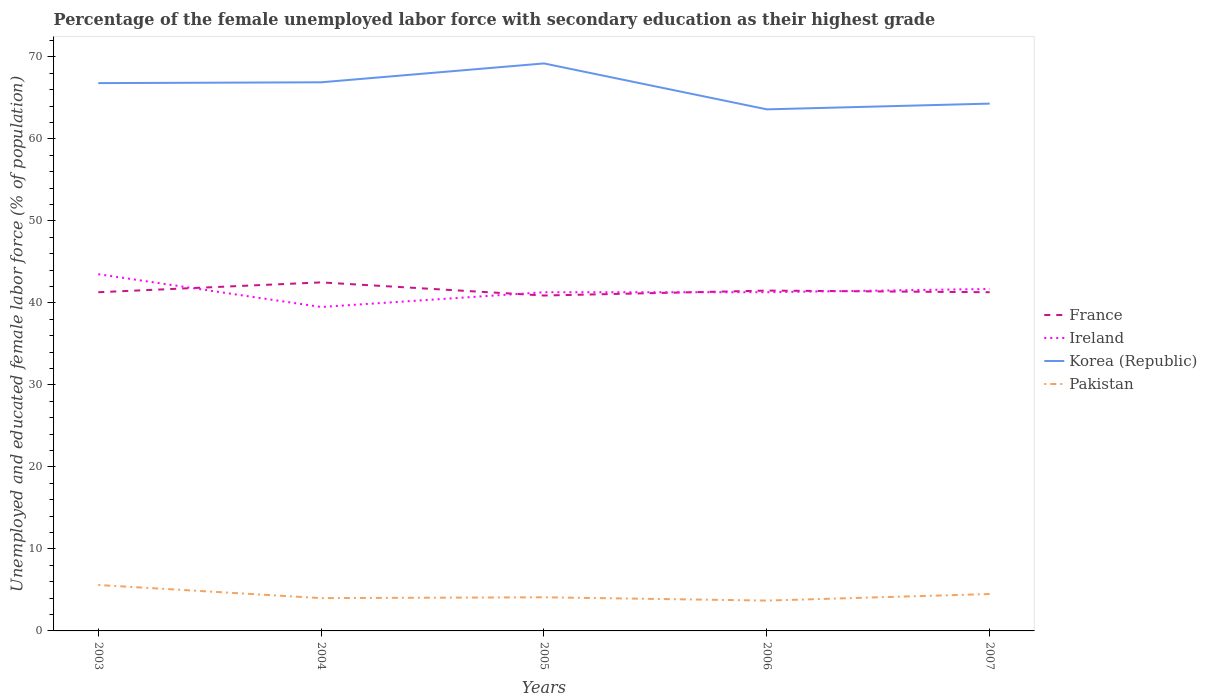Does the line corresponding to Korea (Republic) intersect with the line corresponding to Ireland?
Give a very brief answer. No. Across all years, what is the maximum percentage of the unemployed female labor force with secondary education in Ireland?
Provide a short and direct response. 39.5. What is the total percentage of the unemployed female labor force with secondary education in Ireland in the graph?
Provide a short and direct response. -0.4. What is the difference between the highest and the second highest percentage of the unemployed female labor force with secondary education in France?
Provide a succinct answer. 1.6. What is the difference between the highest and the lowest percentage of the unemployed female labor force with secondary education in Pakistan?
Your response must be concise. 2. Is the percentage of the unemployed female labor force with secondary education in Korea (Republic) strictly greater than the percentage of the unemployed female labor force with secondary education in France over the years?
Offer a terse response. No. How many years are there in the graph?
Give a very brief answer. 5. Does the graph contain any zero values?
Make the answer very short. No. Where does the legend appear in the graph?
Keep it short and to the point. Center right. How many legend labels are there?
Keep it short and to the point. 4. What is the title of the graph?
Provide a short and direct response. Percentage of the female unemployed labor force with secondary education as their highest grade. Does "Senegal" appear as one of the legend labels in the graph?
Give a very brief answer. No. What is the label or title of the Y-axis?
Give a very brief answer. Unemployed and educated female labor force (% of population). What is the Unemployed and educated female labor force (% of population) of France in 2003?
Ensure brevity in your answer.  41.3. What is the Unemployed and educated female labor force (% of population) in Ireland in 2003?
Give a very brief answer. 43.5. What is the Unemployed and educated female labor force (% of population) in Korea (Republic) in 2003?
Keep it short and to the point. 66.8. What is the Unemployed and educated female labor force (% of population) of Pakistan in 2003?
Ensure brevity in your answer.  5.6. What is the Unemployed and educated female labor force (% of population) in France in 2004?
Provide a succinct answer. 42.5. What is the Unemployed and educated female labor force (% of population) in Ireland in 2004?
Offer a very short reply. 39.5. What is the Unemployed and educated female labor force (% of population) of Korea (Republic) in 2004?
Offer a terse response. 66.9. What is the Unemployed and educated female labor force (% of population) in Pakistan in 2004?
Provide a succinct answer. 4. What is the Unemployed and educated female labor force (% of population) of France in 2005?
Offer a very short reply. 40.9. What is the Unemployed and educated female labor force (% of population) in Ireland in 2005?
Ensure brevity in your answer.  41.3. What is the Unemployed and educated female labor force (% of population) in Korea (Republic) in 2005?
Your answer should be very brief. 69.2. What is the Unemployed and educated female labor force (% of population) of Pakistan in 2005?
Your response must be concise. 4.1. What is the Unemployed and educated female labor force (% of population) of France in 2006?
Ensure brevity in your answer.  41.5. What is the Unemployed and educated female labor force (% of population) of Ireland in 2006?
Give a very brief answer. 41.3. What is the Unemployed and educated female labor force (% of population) of Korea (Republic) in 2006?
Provide a short and direct response. 63.6. What is the Unemployed and educated female labor force (% of population) of Pakistan in 2006?
Provide a succinct answer. 3.7. What is the Unemployed and educated female labor force (% of population) in France in 2007?
Give a very brief answer. 41.3. What is the Unemployed and educated female labor force (% of population) in Ireland in 2007?
Provide a succinct answer. 41.7. What is the Unemployed and educated female labor force (% of population) of Korea (Republic) in 2007?
Offer a terse response. 64.3. What is the Unemployed and educated female labor force (% of population) of Pakistan in 2007?
Offer a very short reply. 4.5. Across all years, what is the maximum Unemployed and educated female labor force (% of population) in France?
Your answer should be very brief. 42.5. Across all years, what is the maximum Unemployed and educated female labor force (% of population) in Ireland?
Keep it short and to the point. 43.5. Across all years, what is the maximum Unemployed and educated female labor force (% of population) in Korea (Republic)?
Keep it short and to the point. 69.2. Across all years, what is the maximum Unemployed and educated female labor force (% of population) of Pakistan?
Offer a terse response. 5.6. Across all years, what is the minimum Unemployed and educated female labor force (% of population) of France?
Offer a terse response. 40.9. Across all years, what is the minimum Unemployed and educated female labor force (% of population) of Ireland?
Offer a very short reply. 39.5. Across all years, what is the minimum Unemployed and educated female labor force (% of population) of Korea (Republic)?
Your answer should be compact. 63.6. Across all years, what is the minimum Unemployed and educated female labor force (% of population) in Pakistan?
Your answer should be very brief. 3.7. What is the total Unemployed and educated female labor force (% of population) of France in the graph?
Your answer should be compact. 207.5. What is the total Unemployed and educated female labor force (% of population) of Ireland in the graph?
Offer a terse response. 207.3. What is the total Unemployed and educated female labor force (% of population) in Korea (Republic) in the graph?
Give a very brief answer. 330.8. What is the total Unemployed and educated female labor force (% of population) of Pakistan in the graph?
Offer a very short reply. 21.9. What is the difference between the Unemployed and educated female labor force (% of population) in Ireland in 2003 and that in 2004?
Make the answer very short. 4. What is the difference between the Unemployed and educated female labor force (% of population) of Korea (Republic) in 2003 and that in 2004?
Offer a very short reply. -0.1. What is the difference between the Unemployed and educated female labor force (% of population) in Ireland in 2003 and that in 2005?
Provide a short and direct response. 2.2. What is the difference between the Unemployed and educated female labor force (% of population) in Korea (Republic) in 2003 and that in 2005?
Ensure brevity in your answer.  -2.4. What is the difference between the Unemployed and educated female labor force (% of population) of Korea (Republic) in 2003 and that in 2006?
Ensure brevity in your answer.  3.2. What is the difference between the Unemployed and educated female labor force (% of population) of France in 2003 and that in 2007?
Provide a short and direct response. 0. What is the difference between the Unemployed and educated female labor force (% of population) in Korea (Republic) in 2004 and that in 2005?
Ensure brevity in your answer.  -2.3. What is the difference between the Unemployed and educated female labor force (% of population) in Pakistan in 2004 and that in 2005?
Keep it short and to the point. -0.1. What is the difference between the Unemployed and educated female labor force (% of population) in France in 2004 and that in 2006?
Your response must be concise. 1. What is the difference between the Unemployed and educated female labor force (% of population) in Korea (Republic) in 2004 and that in 2006?
Your answer should be compact. 3.3. What is the difference between the Unemployed and educated female labor force (% of population) of Pakistan in 2004 and that in 2006?
Provide a short and direct response. 0.3. What is the difference between the Unemployed and educated female labor force (% of population) in France in 2004 and that in 2007?
Your answer should be compact. 1.2. What is the difference between the Unemployed and educated female labor force (% of population) in Ireland in 2004 and that in 2007?
Your answer should be very brief. -2.2. What is the difference between the Unemployed and educated female labor force (% of population) in Korea (Republic) in 2004 and that in 2007?
Ensure brevity in your answer.  2.6. What is the difference between the Unemployed and educated female labor force (% of population) in Ireland in 2005 and that in 2006?
Give a very brief answer. 0. What is the difference between the Unemployed and educated female labor force (% of population) of Korea (Republic) in 2005 and that in 2006?
Provide a short and direct response. 5.6. What is the difference between the Unemployed and educated female labor force (% of population) of Pakistan in 2005 and that in 2006?
Offer a terse response. 0.4. What is the difference between the Unemployed and educated female labor force (% of population) in France in 2005 and that in 2007?
Your answer should be very brief. -0.4. What is the difference between the Unemployed and educated female labor force (% of population) of Ireland in 2005 and that in 2007?
Make the answer very short. -0.4. What is the difference between the Unemployed and educated female labor force (% of population) in Korea (Republic) in 2005 and that in 2007?
Offer a very short reply. 4.9. What is the difference between the Unemployed and educated female labor force (% of population) in Korea (Republic) in 2006 and that in 2007?
Provide a short and direct response. -0.7. What is the difference between the Unemployed and educated female labor force (% of population) of France in 2003 and the Unemployed and educated female labor force (% of population) of Ireland in 2004?
Offer a terse response. 1.8. What is the difference between the Unemployed and educated female labor force (% of population) in France in 2003 and the Unemployed and educated female labor force (% of population) in Korea (Republic) in 2004?
Keep it short and to the point. -25.6. What is the difference between the Unemployed and educated female labor force (% of population) in France in 2003 and the Unemployed and educated female labor force (% of population) in Pakistan in 2004?
Ensure brevity in your answer.  37.3. What is the difference between the Unemployed and educated female labor force (% of population) in Ireland in 2003 and the Unemployed and educated female labor force (% of population) in Korea (Republic) in 2004?
Give a very brief answer. -23.4. What is the difference between the Unemployed and educated female labor force (% of population) in Ireland in 2003 and the Unemployed and educated female labor force (% of population) in Pakistan in 2004?
Make the answer very short. 39.5. What is the difference between the Unemployed and educated female labor force (% of population) in Korea (Republic) in 2003 and the Unemployed and educated female labor force (% of population) in Pakistan in 2004?
Offer a very short reply. 62.8. What is the difference between the Unemployed and educated female labor force (% of population) in France in 2003 and the Unemployed and educated female labor force (% of population) in Ireland in 2005?
Offer a very short reply. 0. What is the difference between the Unemployed and educated female labor force (% of population) of France in 2003 and the Unemployed and educated female labor force (% of population) of Korea (Republic) in 2005?
Your answer should be very brief. -27.9. What is the difference between the Unemployed and educated female labor force (% of population) of France in 2003 and the Unemployed and educated female labor force (% of population) of Pakistan in 2005?
Your response must be concise. 37.2. What is the difference between the Unemployed and educated female labor force (% of population) in Ireland in 2003 and the Unemployed and educated female labor force (% of population) in Korea (Republic) in 2005?
Your response must be concise. -25.7. What is the difference between the Unemployed and educated female labor force (% of population) of Ireland in 2003 and the Unemployed and educated female labor force (% of population) of Pakistan in 2005?
Provide a short and direct response. 39.4. What is the difference between the Unemployed and educated female labor force (% of population) of Korea (Republic) in 2003 and the Unemployed and educated female labor force (% of population) of Pakistan in 2005?
Ensure brevity in your answer.  62.7. What is the difference between the Unemployed and educated female labor force (% of population) of France in 2003 and the Unemployed and educated female labor force (% of population) of Ireland in 2006?
Provide a succinct answer. 0. What is the difference between the Unemployed and educated female labor force (% of population) of France in 2003 and the Unemployed and educated female labor force (% of population) of Korea (Republic) in 2006?
Provide a succinct answer. -22.3. What is the difference between the Unemployed and educated female labor force (% of population) in France in 2003 and the Unemployed and educated female labor force (% of population) in Pakistan in 2006?
Ensure brevity in your answer.  37.6. What is the difference between the Unemployed and educated female labor force (% of population) of Ireland in 2003 and the Unemployed and educated female labor force (% of population) of Korea (Republic) in 2006?
Your answer should be compact. -20.1. What is the difference between the Unemployed and educated female labor force (% of population) of Ireland in 2003 and the Unemployed and educated female labor force (% of population) of Pakistan in 2006?
Provide a succinct answer. 39.8. What is the difference between the Unemployed and educated female labor force (% of population) of Korea (Republic) in 2003 and the Unemployed and educated female labor force (% of population) of Pakistan in 2006?
Offer a terse response. 63.1. What is the difference between the Unemployed and educated female labor force (% of population) in France in 2003 and the Unemployed and educated female labor force (% of population) in Korea (Republic) in 2007?
Your answer should be compact. -23. What is the difference between the Unemployed and educated female labor force (% of population) of France in 2003 and the Unemployed and educated female labor force (% of population) of Pakistan in 2007?
Your answer should be very brief. 36.8. What is the difference between the Unemployed and educated female labor force (% of population) in Ireland in 2003 and the Unemployed and educated female labor force (% of population) in Korea (Republic) in 2007?
Your answer should be compact. -20.8. What is the difference between the Unemployed and educated female labor force (% of population) in Korea (Republic) in 2003 and the Unemployed and educated female labor force (% of population) in Pakistan in 2007?
Offer a very short reply. 62.3. What is the difference between the Unemployed and educated female labor force (% of population) of France in 2004 and the Unemployed and educated female labor force (% of population) of Korea (Republic) in 2005?
Give a very brief answer. -26.7. What is the difference between the Unemployed and educated female labor force (% of population) of France in 2004 and the Unemployed and educated female labor force (% of population) of Pakistan in 2005?
Provide a succinct answer. 38.4. What is the difference between the Unemployed and educated female labor force (% of population) in Ireland in 2004 and the Unemployed and educated female labor force (% of population) in Korea (Republic) in 2005?
Provide a succinct answer. -29.7. What is the difference between the Unemployed and educated female labor force (% of population) in Ireland in 2004 and the Unemployed and educated female labor force (% of population) in Pakistan in 2005?
Offer a very short reply. 35.4. What is the difference between the Unemployed and educated female labor force (% of population) of Korea (Republic) in 2004 and the Unemployed and educated female labor force (% of population) of Pakistan in 2005?
Ensure brevity in your answer.  62.8. What is the difference between the Unemployed and educated female labor force (% of population) in France in 2004 and the Unemployed and educated female labor force (% of population) in Korea (Republic) in 2006?
Your response must be concise. -21.1. What is the difference between the Unemployed and educated female labor force (% of population) in France in 2004 and the Unemployed and educated female labor force (% of population) in Pakistan in 2006?
Provide a succinct answer. 38.8. What is the difference between the Unemployed and educated female labor force (% of population) in Ireland in 2004 and the Unemployed and educated female labor force (% of population) in Korea (Republic) in 2006?
Offer a terse response. -24.1. What is the difference between the Unemployed and educated female labor force (% of population) of Ireland in 2004 and the Unemployed and educated female labor force (% of population) of Pakistan in 2006?
Your answer should be compact. 35.8. What is the difference between the Unemployed and educated female labor force (% of population) of Korea (Republic) in 2004 and the Unemployed and educated female labor force (% of population) of Pakistan in 2006?
Ensure brevity in your answer.  63.2. What is the difference between the Unemployed and educated female labor force (% of population) in France in 2004 and the Unemployed and educated female labor force (% of population) in Korea (Republic) in 2007?
Keep it short and to the point. -21.8. What is the difference between the Unemployed and educated female labor force (% of population) in France in 2004 and the Unemployed and educated female labor force (% of population) in Pakistan in 2007?
Your answer should be very brief. 38. What is the difference between the Unemployed and educated female labor force (% of population) of Ireland in 2004 and the Unemployed and educated female labor force (% of population) of Korea (Republic) in 2007?
Your answer should be very brief. -24.8. What is the difference between the Unemployed and educated female labor force (% of population) of Ireland in 2004 and the Unemployed and educated female labor force (% of population) of Pakistan in 2007?
Offer a terse response. 35. What is the difference between the Unemployed and educated female labor force (% of population) of Korea (Republic) in 2004 and the Unemployed and educated female labor force (% of population) of Pakistan in 2007?
Offer a terse response. 62.4. What is the difference between the Unemployed and educated female labor force (% of population) of France in 2005 and the Unemployed and educated female labor force (% of population) of Ireland in 2006?
Offer a very short reply. -0.4. What is the difference between the Unemployed and educated female labor force (% of population) of France in 2005 and the Unemployed and educated female labor force (% of population) of Korea (Republic) in 2006?
Give a very brief answer. -22.7. What is the difference between the Unemployed and educated female labor force (% of population) in France in 2005 and the Unemployed and educated female labor force (% of population) in Pakistan in 2006?
Your response must be concise. 37.2. What is the difference between the Unemployed and educated female labor force (% of population) of Ireland in 2005 and the Unemployed and educated female labor force (% of population) of Korea (Republic) in 2006?
Your answer should be compact. -22.3. What is the difference between the Unemployed and educated female labor force (% of population) of Ireland in 2005 and the Unemployed and educated female labor force (% of population) of Pakistan in 2006?
Make the answer very short. 37.6. What is the difference between the Unemployed and educated female labor force (% of population) of Korea (Republic) in 2005 and the Unemployed and educated female labor force (% of population) of Pakistan in 2006?
Give a very brief answer. 65.5. What is the difference between the Unemployed and educated female labor force (% of population) of France in 2005 and the Unemployed and educated female labor force (% of population) of Ireland in 2007?
Keep it short and to the point. -0.8. What is the difference between the Unemployed and educated female labor force (% of population) in France in 2005 and the Unemployed and educated female labor force (% of population) in Korea (Republic) in 2007?
Make the answer very short. -23.4. What is the difference between the Unemployed and educated female labor force (% of population) in France in 2005 and the Unemployed and educated female labor force (% of population) in Pakistan in 2007?
Provide a short and direct response. 36.4. What is the difference between the Unemployed and educated female labor force (% of population) of Ireland in 2005 and the Unemployed and educated female labor force (% of population) of Pakistan in 2007?
Your response must be concise. 36.8. What is the difference between the Unemployed and educated female labor force (% of population) of Korea (Republic) in 2005 and the Unemployed and educated female labor force (% of population) of Pakistan in 2007?
Give a very brief answer. 64.7. What is the difference between the Unemployed and educated female labor force (% of population) of France in 2006 and the Unemployed and educated female labor force (% of population) of Ireland in 2007?
Your answer should be very brief. -0.2. What is the difference between the Unemployed and educated female labor force (% of population) of France in 2006 and the Unemployed and educated female labor force (% of population) of Korea (Republic) in 2007?
Ensure brevity in your answer.  -22.8. What is the difference between the Unemployed and educated female labor force (% of population) in France in 2006 and the Unemployed and educated female labor force (% of population) in Pakistan in 2007?
Provide a short and direct response. 37. What is the difference between the Unemployed and educated female labor force (% of population) of Ireland in 2006 and the Unemployed and educated female labor force (% of population) of Korea (Republic) in 2007?
Make the answer very short. -23. What is the difference between the Unemployed and educated female labor force (% of population) of Ireland in 2006 and the Unemployed and educated female labor force (% of population) of Pakistan in 2007?
Provide a short and direct response. 36.8. What is the difference between the Unemployed and educated female labor force (% of population) in Korea (Republic) in 2006 and the Unemployed and educated female labor force (% of population) in Pakistan in 2007?
Give a very brief answer. 59.1. What is the average Unemployed and educated female labor force (% of population) in France per year?
Offer a terse response. 41.5. What is the average Unemployed and educated female labor force (% of population) of Ireland per year?
Keep it short and to the point. 41.46. What is the average Unemployed and educated female labor force (% of population) in Korea (Republic) per year?
Make the answer very short. 66.16. What is the average Unemployed and educated female labor force (% of population) in Pakistan per year?
Provide a short and direct response. 4.38. In the year 2003, what is the difference between the Unemployed and educated female labor force (% of population) in France and Unemployed and educated female labor force (% of population) in Korea (Republic)?
Offer a terse response. -25.5. In the year 2003, what is the difference between the Unemployed and educated female labor force (% of population) of France and Unemployed and educated female labor force (% of population) of Pakistan?
Offer a very short reply. 35.7. In the year 2003, what is the difference between the Unemployed and educated female labor force (% of population) in Ireland and Unemployed and educated female labor force (% of population) in Korea (Republic)?
Keep it short and to the point. -23.3. In the year 2003, what is the difference between the Unemployed and educated female labor force (% of population) of Ireland and Unemployed and educated female labor force (% of population) of Pakistan?
Make the answer very short. 37.9. In the year 2003, what is the difference between the Unemployed and educated female labor force (% of population) in Korea (Republic) and Unemployed and educated female labor force (% of population) in Pakistan?
Provide a succinct answer. 61.2. In the year 2004, what is the difference between the Unemployed and educated female labor force (% of population) in France and Unemployed and educated female labor force (% of population) in Korea (Republic)?
Offer a terse response. -24.4. In the year 2004, what is the difference between the Unemployed and educated female labor force (% of population) in France and Unemployed and educated female labor force (% of population) in Pakistan?
Ensure brevity in your answer.  38.5. In the year 2004, what is the difference between the Unemployed and educated female labor force (% of population) in Ireland and Unemployed and educated female labor force (% of population) in Korea (Republic)?
Offer a terse response. -27.4. In the year 2004, what is the difference between the Unemployed and educated female labor force (% of population) of Ireland and Unemployed and educated female labor force (% of population) of Pakistan?
Ensure brevity in your answer.  35.5. In the year 2004, what is the difference between the Unemployed and educated female labor force (% of population) of Korea (Republic) and Unemployed and educated female labor force (% of population) of Pakistan?
Your answer should be compact. 62.9. In the year 2005, what is the difference between the Unemployed and educated female labor force (% of population) in France and Unemployed and educated female labor force (% of population) in Korea (Republic)?
Make the answer very short. -28.3. In the year 2005, what is the difference between the Unemployed and educated female labor force (% of population) of France and Unemployed and educated female labor force (% of population) of Pakistan?
Your answer should be very brief. 36.8. In the year 2005, what is the difference between the Unemployed and educated female labor force (% of population) of Ireland and Unemployed and educated female labor force (% of population) of Korea (Republic)?
Offer a terse response. -27.9. In the year 2005, what is the difference between the Unemployed and educated female labor force (% of population) in Ireland and Unemployed and educated female labor force (% of population) in Pakistan?
Offer a very short reply. 37.2. In the year 2005, what is the difference between the Unemployed and educated female labor force (% of population) in Korea (Republic) and Unemployed and educated female labor force (% of population) in Pakistan?
Your answer should be very brief. 65.1. In the year 2006, what is the difference between the Unemployed and educated female labor force (% of population) in France and Unemployed and educated female labor force (% of population) in Ireland?
Your answer should be compact. 0.2. In the year 2006, what is the difference between the Unemployed and educated female labor force (% of population) in France and Unemployed and educated female labor force (% of population) in Korea (Republic)?
Your answer should be compact. -22.1. In the year 2006, what is the difference between the Unemployed and educated female labor force (% of population) in France and Unemployed and educated female labor force (% of population) in Pakistan?
Give a very brief answer. 37.8. In the year 2006, what is the difference between the Unemployed and educated female labor force (% of population) in Ireland and Unemployed and educated female labor force (% of population) in Korea (Republic)?
Your answer should be very brief. -22.3. In the year 2006, what is the difference between the Unemployed and educated female labor force (% of population) in Ireland and Unemployed and educated female labor force (% of population) in Pakistan?
Provide a short and direct response. 37.6. In the year 2006, what is the difference between the Unemployed and educated female labor force (% of population) of Korea (Republic) and Unemployed and educated female labor force (% of population) of Pakistan?
Your answer should be compact. 59.9. In the year 2007, what is the difference between the Unemployed and educated female labor force (% of population) in France and Unemployed and educated female labor force (% of population) in Pakistan?
Ensure brevity in your answer.  36.8. In the year 2007, what is the difference between the Unemployed and educated female labor force (% of population) in Ireland and Unemployed and educated female labor force (% of population) in Korea (Republic)?
Offer a terse response. -22.6. In the year 2007, what is the difference between the Unemployed and educated female labor force (% of population) in Ireland and Unemployed and educated female labor force (% of population) in Pakistan?
Your response must be concise. 37.2. In the year 2007, what is the difference between the Unemployed and educated female labor force (% of population) of Korea (Republic) and Unemployed and educated female labor force (% of population) of Pakistan?
Your response must be concise. 59.8. What is the ratio of the Unemployed and educated female labor force (% of population) of France in 2003 to that in 2004?
Ensure brevity in your answer.  0.97. What is the ratio of the Unemployed and educated female labor force (% of population) of Ireland in 2003 to that in 2004?
Offer a very short reply. 1.1. What is the ratio of the Unemployed and educated female labor force (% of population) in Korea (Republic) in 2003 to that in 2004?
Give a very brief answer. 1. What is the ratio of the Unemployed and educated female labor force (% of population) of France in 2003 to that in 2005?
Ensure brevity in your answer.  1.01. What is the ratio of the Unemployed and educated female labor force (% of population) of Ireland in 2003 to that in 2005?
Offer a terse response. 1.05. What is the ratio of the Unemployed and educated female labor force (% of population) in Korea (Republic) in 2003 to that in 2005?
Offer a very short reply. 0.97. What is the ratio of the Unemployed and educated female labor force (% of population) in Pakistan in 2003 to that in 2005?
Make the answer very short. 1.37. What is the ratio of the Unemployed and educated female labor force (% of population) in Ireland in 2003 to that in 2006?
Your response must be concise. 1.05. What is the ratio of the Unemployed and educated female labor force (% of population) of Korea (Republic) in 2003 to that in 2006?
Your answer should be very brief. 1.05. What is the ratio of the Unemployed and educated female labor force (% of population) of Pakistan in 2003 to that in 2006?
Your answer should be very brief. 1.51. What is the ratio of the Unemployed and educated female labor force (% of population) in France in 2003 to that in 2007?
Your answer should be compact. 1. What is the ratio of the Unemployed and educated female labor force (% of population) of Ireland in 2003 to that in 2007?
Your response must be concise. 1.04. What is the ratio of the Unemployed and educated female labor force (% of population) of Korea (Republic) in 2003 to that in 2007?
Offer a terse response. 1.04. What is the ratio of the Unemployed and educated female labor force (% of population) in Pakistan in 2003 to that in 2007?
Give a very brief answer. 1.24. What is the ratio of the Unemployed and educated female labor force (% of population) in France in 2004 to that in 2005?
Your answer should be very brief. 1.04. What is the ratio of the Unemployed and educated female labor force (% of population) of Ireland in 2004 to that in 2005?
Give a very brief answer. 0.96. What is the ratio of the Unemployed and educated female labor force (% of population) in Korea (Republic) in 2004 to that in 2005?
Ensure brevity in your answer.  0.97. What is the ratio of the Unemployed and educated female labor force (% of population) in Pakistan in 2004 to that in 2005?
Offer a very short reply. 0.98. What is the ratio of the Unemployed and educated female labor force (% of population) in France in 2004 to that in 2006?
Provide a succinct answer. 1.02. What is the ratio of the Unemployed and educated female labor force (% of population) of Ireland in 2004 to that in 2006?
Give a very brief answer. 0.96. What is the ratio of the Unemployed and educated female labor force (% of population) in Korea (Republic) in 2004 to that in 2006?
Keep it short and to the point. 1.05. What is the ratio of the Unemployed and educated female labor force (% of population) in Pakistan in 2004 to that in 2006?
Keep it short and to the point. 1.08. What is the ratio of the Unemployed and educated female labor force (% of population) of France in 2004 to that in 2007?
Your response must be concise. 1.03. What is the ratio of the Unemployed and educated female labor force (% of population) of Ireland in 2004 to that in 2007?
Offer a terse response. 0.95. What is the ratio of the Unemployed and educated female labor force (% of population) in Korea (Republic) in 2004 to that in 2007?
Offer a terse response. 1.04. What is the ratio of the Unemployed and educated female labor force (% of population) of Pakistan in 2004 to that in 2007?
Give a very brief answer. 0.89. What is the ratio of the Unemployed and educated female labor force (% of population) in France in 2005 to that in 2006?
Offer a terse response. 0.99. What is the ratio of the Unemployed and educated female labor force (% of population) in Korea (Republic) in 2005 to that in 2006?
Ensure brevity in your answer.  1.09. What is the ratio of the Unemployed and educated female labor force (% of population) of Pakistan in 2005 to that in 2006?
Offer a very short reply. 1.11. What is the ratio of the Unemployed and educated female labor force (% of population) in France in 2005 to that in 2007?
Offer a very short reply. 0.99. What is the ratio of the Unemployed and educated female labor force (% of population) in Korea (Republic) in 2005 to that in 2007?
Provide a succinct answer. 1.08. What is the ratio of the Unemployed and educated female labor force (% of population) in Pakistan in 2005 to that in 2007?
Give a very brief answer. 0.91. What is the ratio of the Unemployed and educated female labor force (% of population) in France in 2006 to that in 2007?
Make the answer very short. 1. What is the ratio of the Unemployed and educated female labor force (% of population) of Korea (Republic) in 2006 to that in 2007?
Keep it short and to the point. 0.99. What is the ratio of the Unemployed and educated female labor force (% of population) of Pakistan in 2006 to that in 2007?
Your answer should be compact. 0.82. What is the difference between the highest and the second highest Unemployed and educated female labor force (% of population) of France?
Ensure brevity in your answer.  1. What is the difference between the highest and the second highest Unemployed and educated female labor force (% of population) of Korea (Republic)?
Offer a terse response. 2.3. What is the difference between the highest and the second highest Unemployed and educated female labor force (% of population) in Pakistan?
Provide a short and direct response. 1.1. What is the difference between the highest and the lowest Unemployed and educated female labor force (% of population) of Korea (Republic)?
Your answer should be compact. 5.6. What is the difference between the highest and the lowest Unemployed and educated female labor force (% of population) in Pakistan?
Offer a terse response. 1.9. 